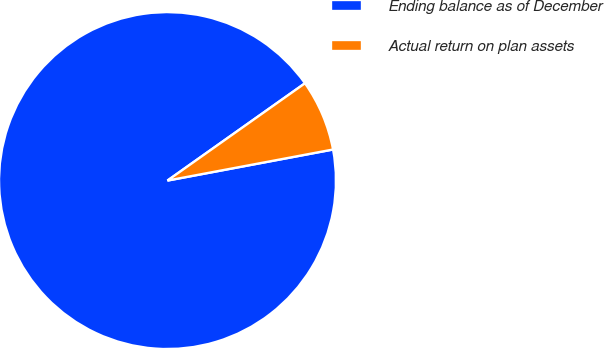Convert chart. <chart><loc_0><loc_0><loc_500><loc_500><pie_chart><fcel>Ending balance as of December<fcel>Actual return on plan assets<nl><fcel>93.15%<fcel>6.85%<nl></chart> 